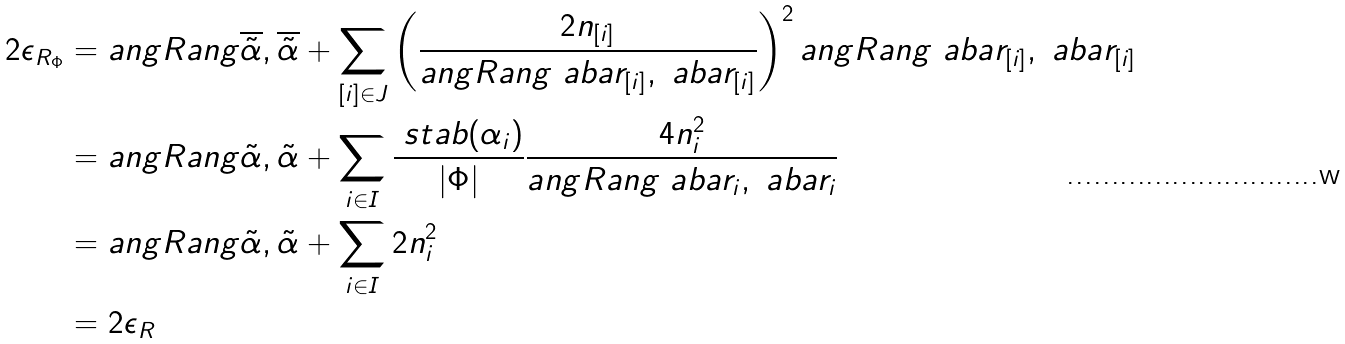Convert formula to latex. <formula><loc_0><loc_0><loc_500><loc_500>2 \epsilon _ { R _ { \Phi } } & = \L a n g R a n g { \overline { \tilde { \alpha } } , \overline { \tilde { \alpha } } } + \sum _ { [ i ] \in J } \left ( \frac { 2 n _ { [ i ] } } { \L a n g R a n g { \ a b a r _ { [ i ] } , \ a b a r _ { [ i ] } } } \right ) ^ { 2 } \L a n g R a n g { \ a b a r _ { [ i ] } , \ a b a r _ { [ i ] } } \\ & = \L a n g R a n g { \tilde { \alpha } , \tilde { \alpha } } + \sum _ { i \in I } \frac { \ s t a b ( \alpha _ { i } ) } { | \Phi | } \frac { 4 n _ { i } ^ { 2 } } { \L a n g R a n g { \ a b a r _ { i } , \ a b a r _ { i } } } \\ & = \L a n g R a n g { \tilde { \alpha } , \tilde { \alpha } } + \sum _ { i \in I } 2 n _ { i } ^ { 2 } \\ & = 2 \epsilon _ { R }</formula> 